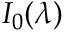Convert formula to latex. <formula><loc_0><loc_0><loc_500><loc_500>I _ { 0 } ( \lambda )</formula> 